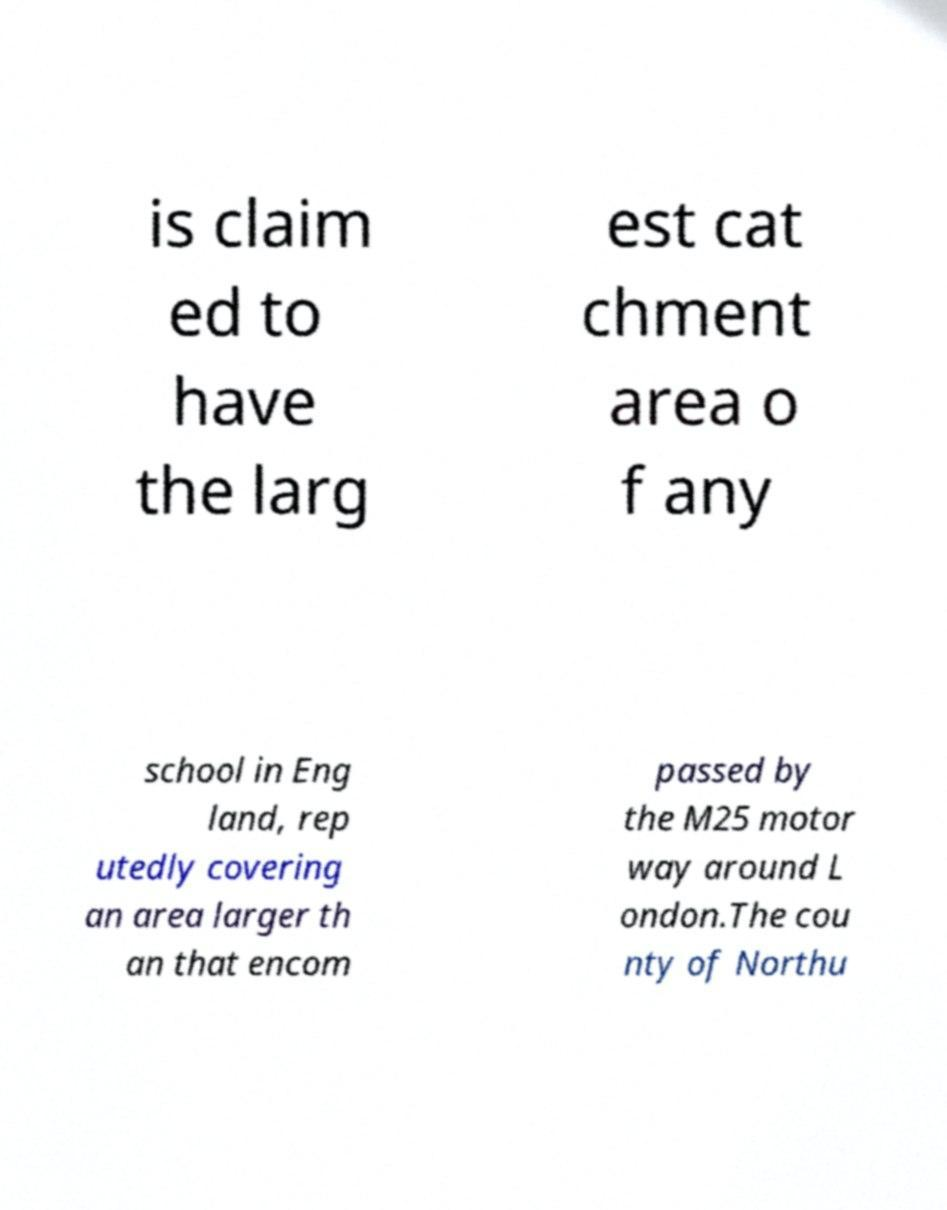What messages or text are displayed in this image? I need them in a readable, typed format. is claim ed to have the larg est cat chment area o f any school in Eng land, rep utedly covering an area larger th an that encom passed by the M25 motor way around L ondon.The cou nty of Northu 